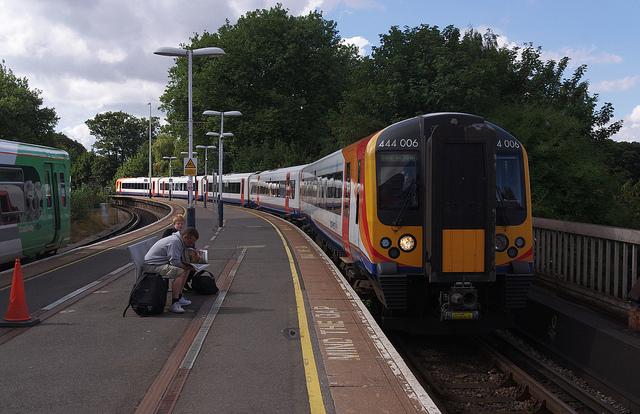What is the train number?
Concise answer only. 444006. What side of the train are the people sitting?
Answer briefly. Left. Can you see cones?
Keep it brief. Yes. 